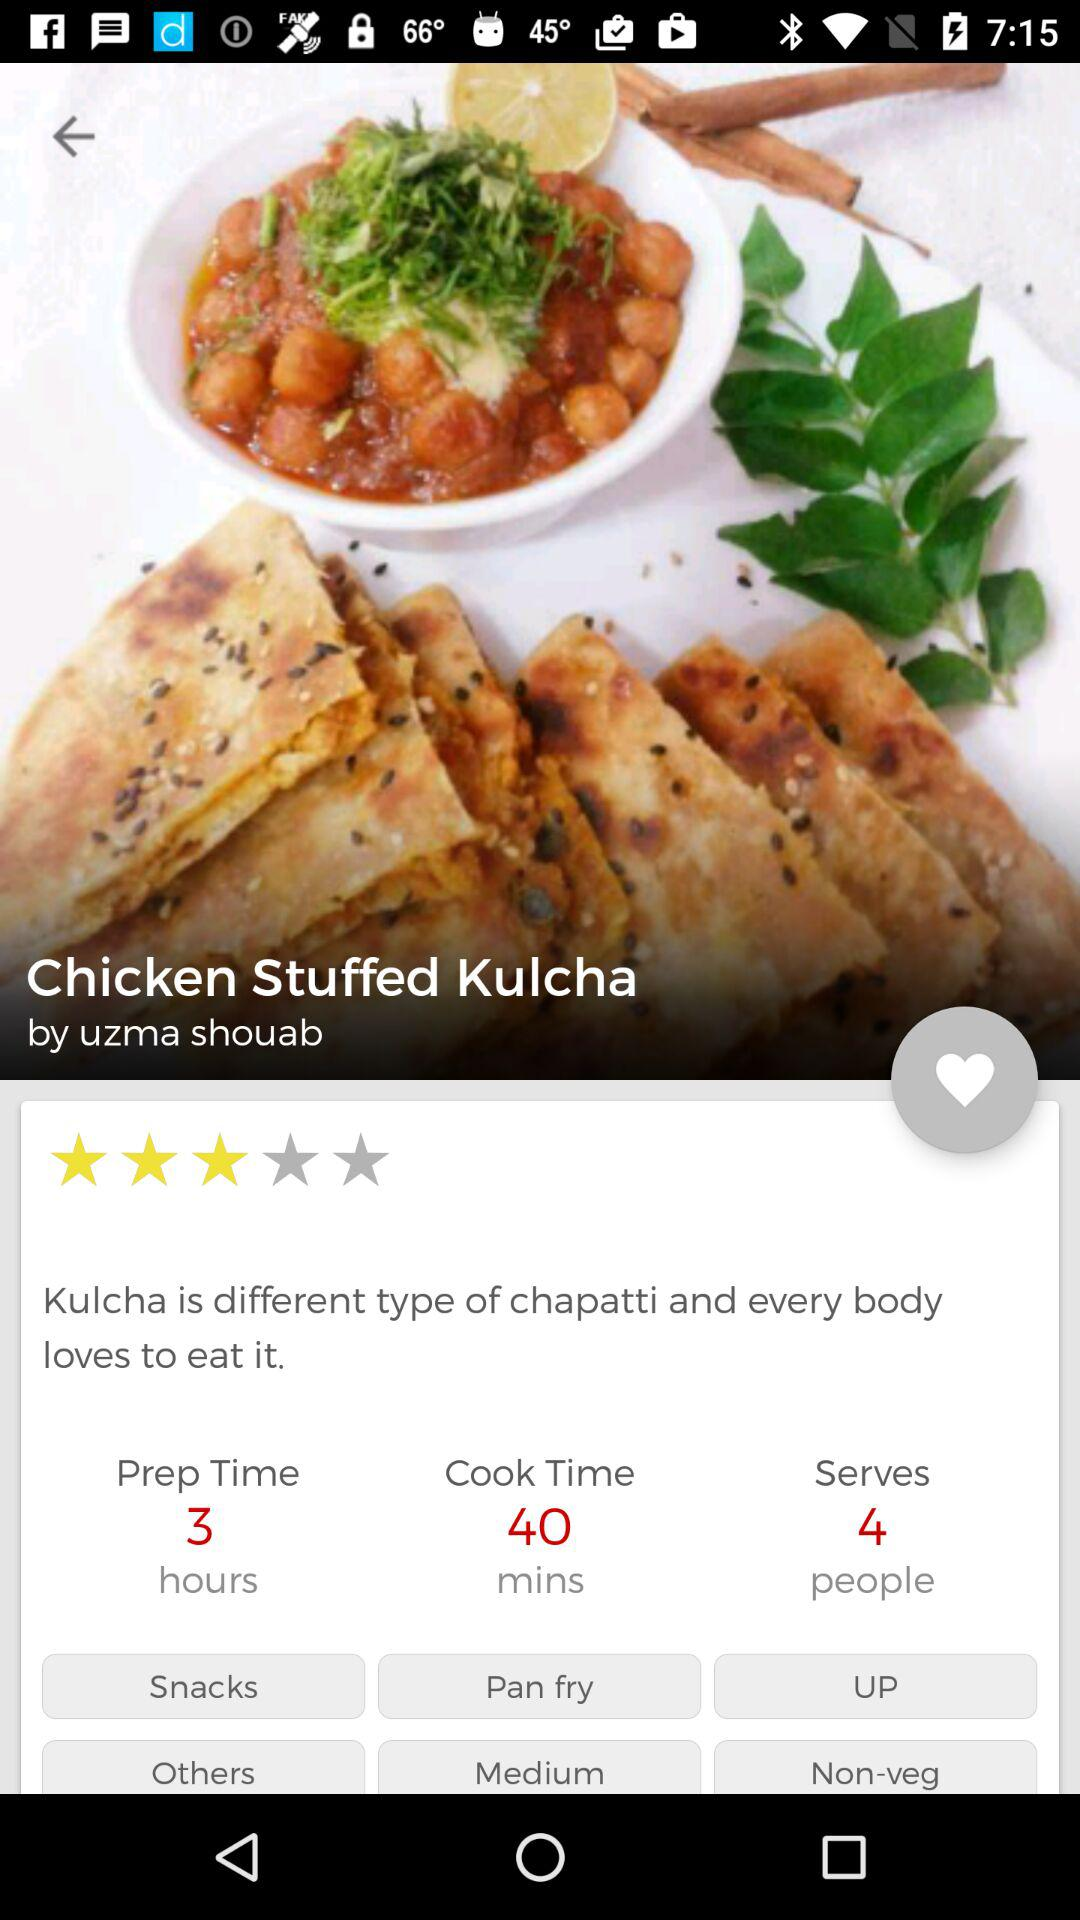How many ingredients are needed to make "Chicken Stuffed Kulcha"?
When the provided information is insufficient, respond with <no answer>. <no answer> 